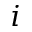<formula> <loc_0><loc_0><loc_500><loc_500>i</formula> 